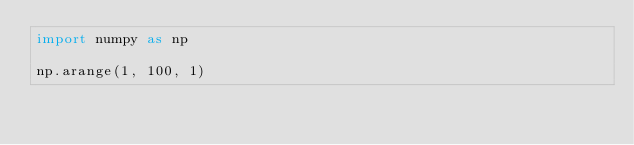<code> <loc_0><loc_0><loc_500><loc_500><_Python_>import numpy as np 

np.arange(1, 100, 1)
</code> 